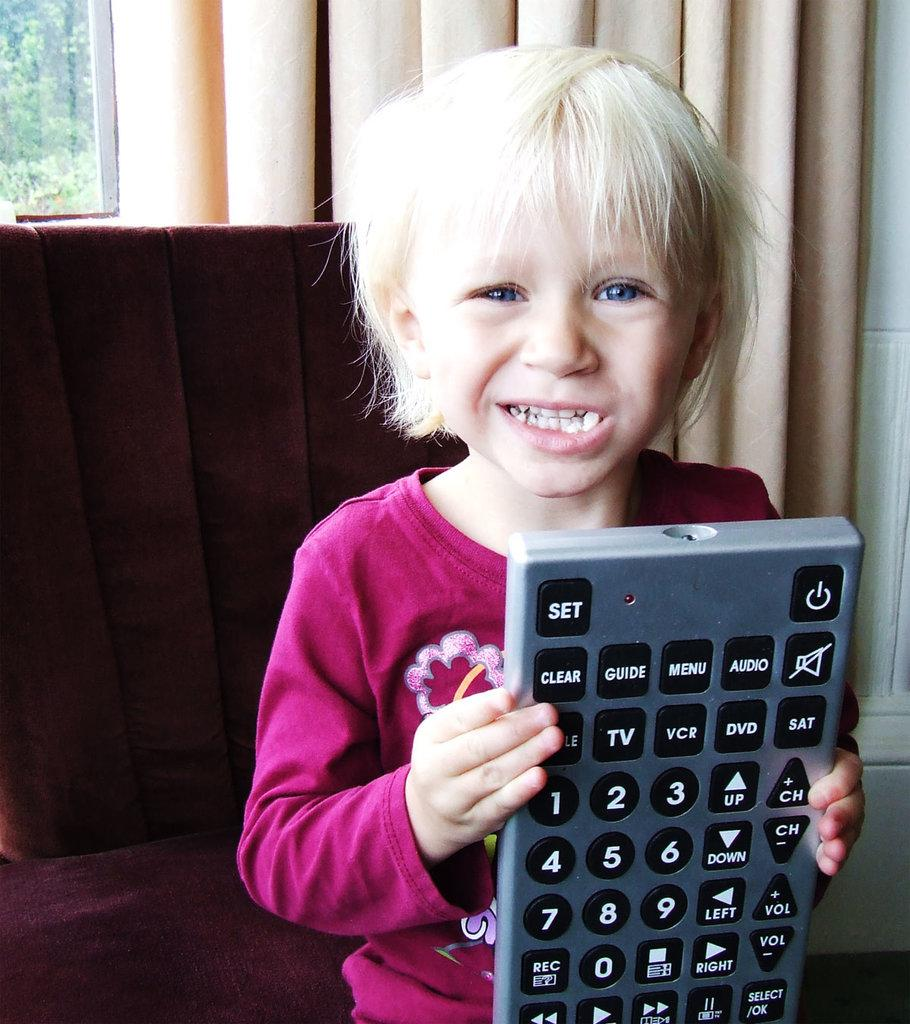<image>
Give a short and clear explanation of the subsequent image. A child is holding a giant remote that has a menu button. 